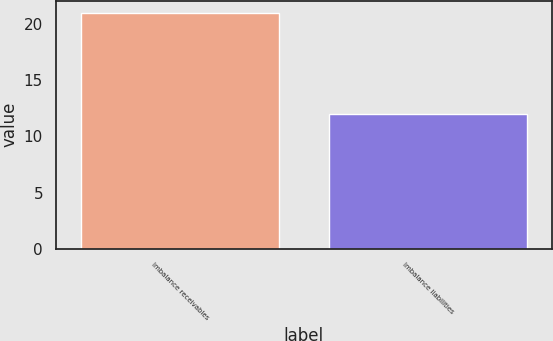Convert chart. <chart><loc_0><loc_0><loc_500><loc_500><bar_chart><fcel>Imbalance receivables<fcel>Imbalance liabilities<nl><fcel>21<fcel>12<nl></chart> 